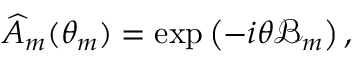Convert formula to latex. <formula><loc_0><loc_0><loc_500><loc_500>\begin{array} { r } { \widehat { A } _ { m } ( \theta _ { m } ) = \exp \left ( - i \theta \mathcal { B } _ { m } \right ) , } \end{array}</formula> 